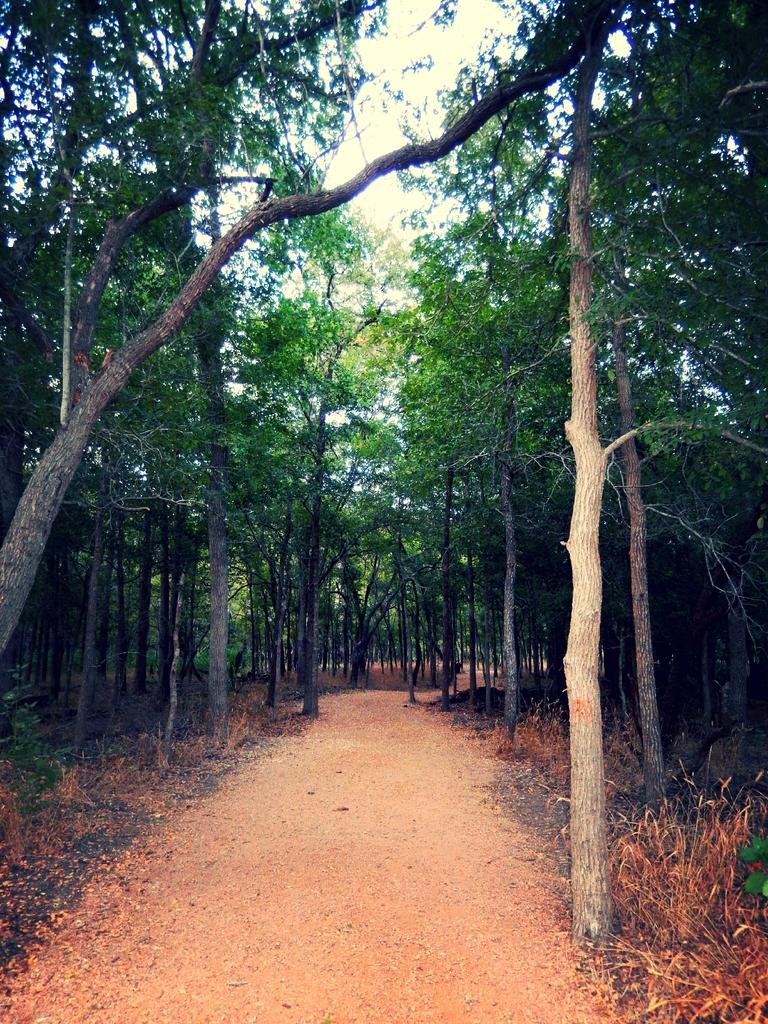Where was the image taken? The image was taken outdoors. What type of ground is visible in the image? There is a ground with grass in the image. What can be seen in the background of the image? There are many trees in the background of the image. What is the condition of the zephyr in the image? There is no mention of a zephyr in the image, so we cannot determine its condition. 